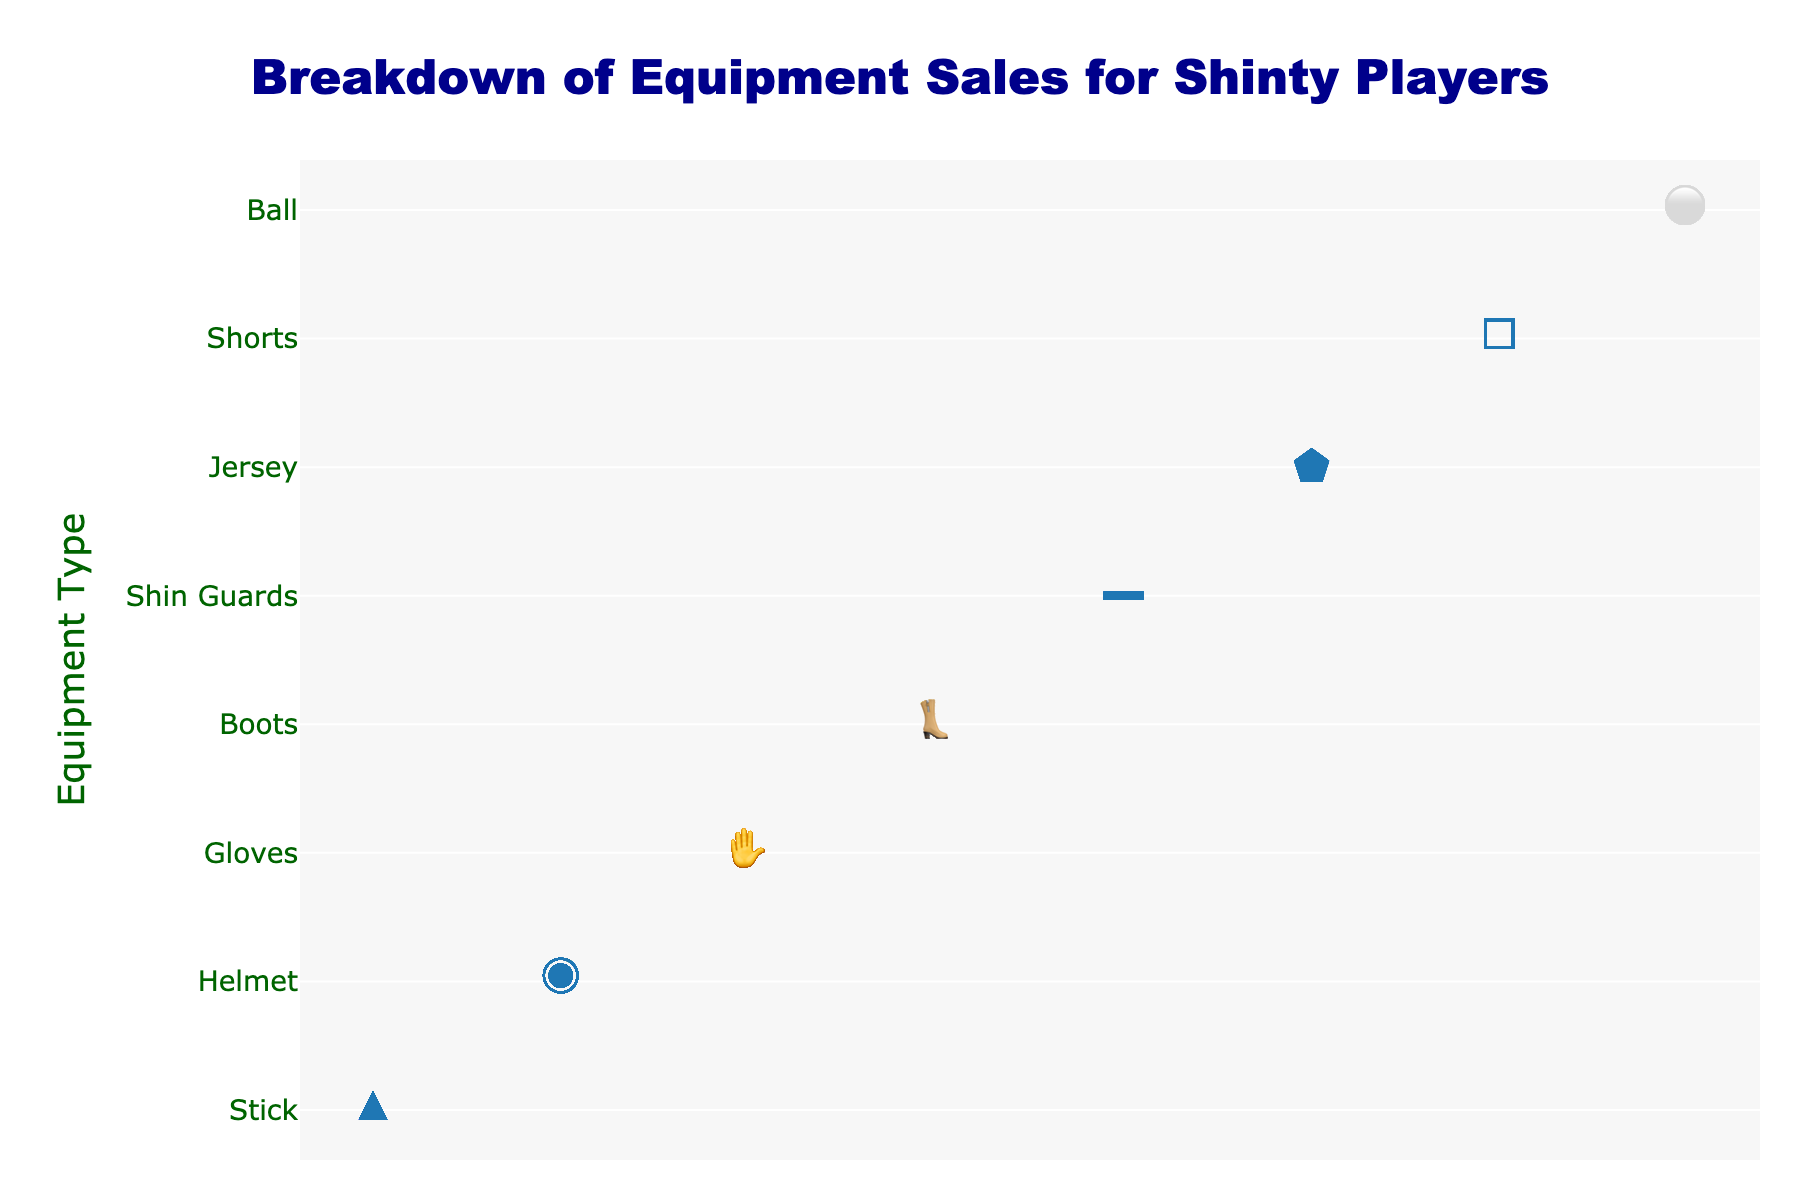What is the title of the plot? The title is typically positioned at the top of the plot and usually states the main topic or insight that the plot is trying to convey. In this case, it tells us about the breakdown of equipment sales.
Answer: Breakdown of Equipment Sales for Shinty Players Which equipment type has the highest sales count? To determine this, we need to look at the equipment type that has the most icons in its row. The equipment type 'Stick' has the most icons.
Answer: Stick How many helmets were sold? Count the number of icons representing helmets (represented by '◉') in the corresponding row.
Answer: 75 Which equipment type has the least sales? Identify the row with the fewest icons. The equipment type 'Ball' has the least sales.
Answer: Ball What is the total sales count for all the equipment types combined? Add up all the sales counts: 100 (Stick) + 75 (Helmet) + 60 (Gloves) + 50 (Boots) + 40 (Shin Guards) + 30 (Jersey) + 25 (Shorts) + 20 (Ball) = 400.
Answer: 400 Are there more boots or shin guards sold? Compare the number of icons in the rows for Boots and Shin Guards. There are more Boots sold than Shin Guards.
Answer: Boots What is the difference in sales between the most and least sold equipment types? Identify the counts for the most sold (Stick, 100) and least sold (Ball, 20) equipment types, then subtract the two: 100 - 20 = 80.
Answer: 80 Which equipment types have more than 50 sales? Identify equipment types with a number of icons greater than 50: Stick (100), Helmet (75), Gloves (60).
Answer: Stick, Helmet, Gloves How many more gloves were sold compared to shorts? Identify the counts for Gloves (60) and Shorts (25), then subtract the two: 60 - 25 = 35.
Answer: 35 Is the sales count for jerseys higher or lower than for shin guards? Compare the number of icons in the rows for Jersey and Shin Guards. The number of icons for Jerseys (30) is lower than for Shin Guards (40).
Answer: Lower 